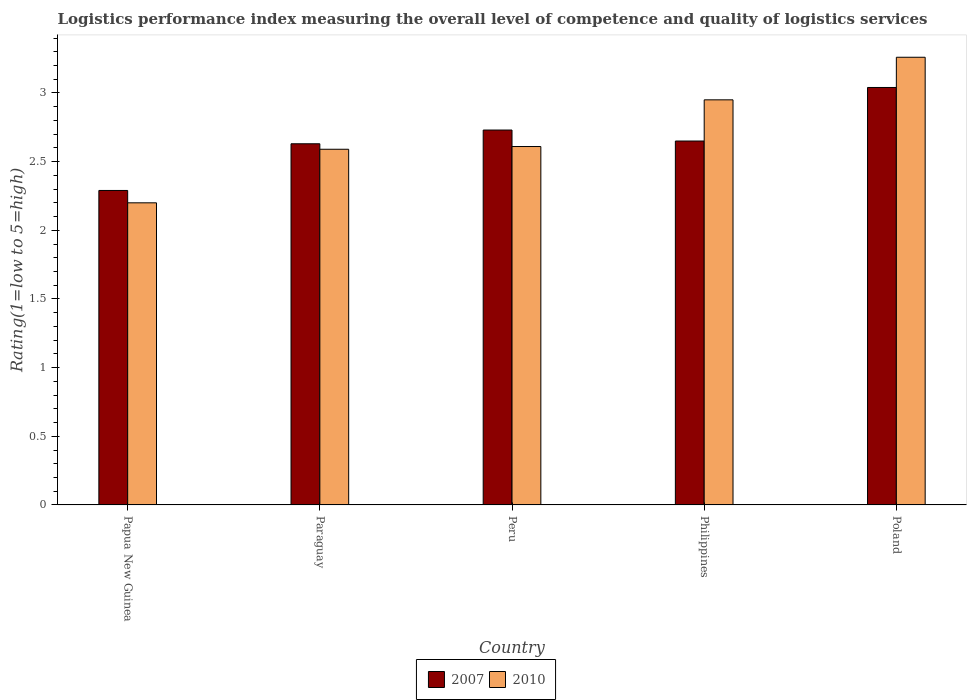How many different coloured bars are there?
Offer a terse response. 2. Are the number of bars per tick equal to the number of legend labels?
Offer a very short reply. Yes. How many bars are there on the 4th tick from the right?
Offer a terse response. 2. What is the label of the 2nd group of bars from the left?
Provide a succinct answer. Paraguay. What is the Logistic performance index in 2007 in Peru?
Your response must be concise. 2.73. Across all countries, what is the maximum Logistic performance index in 2007?
Your response must be concise. 3.04. In which country was the Logistic performance index in 2007 maximum?
Give a very brief answer. Poland. In which country was the Logistic performance index in 2010 minimum?
Provide a short and direct response. Papua New Guinea. What is the total Logistic performance index in 2010 in the graph?
Keep it short and to the point. 13.61. What is the difference between the Logistic performance index in 2010 in Philippines and that in Poland?
Provide a succinct answer. -0.31. What is the difference between the Logistic performance index in 2007 in Paraguay and the Logistic performance index in 2010 in Philippines?
Keep it short and to the point. -0.32. What is the average Logistic performance index in 2010 per country?
Your response must be concise. 2.72. What is the difference between the Logistic performance index of/in 2010 and Logistic performance index of/in 2007 in Philippines?
Your answer should be compact. 0.3. What is the ratio of the Logistic performance index in 2010 in Paraguay to that in Poland?
Make the answer very short. 0.79. Is the Logistic performance index in 2007 in Paraguay less than that in Philippines?
Offer a very short reply. Yes. What is the difference between the highest and the second highest Logistic performance index in 2010?
Provide a succinct answer. -0.34. What is the difference between the highest and the lowest Logistic performance index in 2010?
Ensure brevity in your answer.  1.06. What does the 2nd bar from the left in Poland represents?
Your answer should be very brief. 2010. What does the 2nd bar from the right in Peru represents?
Your answer should be compact. 2007. How many bars are there?
Provide a short and direct response. 10. Are all the bars in the graph horizontal?
Keep it short and to the point. No. What is the difference between two consecutive major ticks on the Y-axis?
Give a very brief answer. 0.5. Does the graph contain any zero values?
Ensure brevity in your answer.  No. How many legend labels are there?
Offer a terse response. 2. What is the title of the graph?
Make the answer very short. Logistics performance index measuring the overall level of competence and quality of logistics services. Does "1973" appear as one of the legend labels in the graph?
Provide a short and direct response. No. What is the label or title of the X-axis?
Your answer should be compact. Country. What is the label or title of the Y-axis?
Make the answer very short. Rating(1=low to 5=high). What is the Rating(1=low to 5=high) in 2007 in Papua New Guinea?
Give a very brief answer. 2.29. What is the Rating(1=low to 5=high) of 2010 in Papua New Guinea?
Make the answer very short. 2.2. What is the Rating(1=low to 5=high) in 2007 in Paraguay?
Give a very brief answer. 2.63. What is the Rating(1=low to 5=high) in 2010 in Paraguay?
Make the answer very short. 2.59. What is the Rating(1=low to 5=high) of 2007 in Peru?
Offer a terse response. 2.73. What is the Rating(1=low to 5=high) of 2010 in Peru?
Your response must be concise. 2.61. What is the Rating(1=low to 5=high) of 2007 in Philippines?
Your answer should be very brief. 2.65. What is the Rating(1=low to 5=high) in 2010 in Philippines?
Make the answer very short. 2.95. What is the Rating(1=low to 5=high) in 2007 in Poland?
Ensure brevity in your answer.  3.04. What is the Rating(1=low to 5=high) of 2010 in Poland?
Provide a succinct answer. 3.26. Across all countries, what is the maximum Rating(1=low to 5=high) in 2007?
Your response must be concise. 3.04. Across all countries, what is the maximum Rating(1=low to 5=high) in 2010?
Keep it short and to the point. 3.26. Across all countries, what is the minimum Rating(1=low to 5=high) of 2007?
Ensure brevity in your answer.  2.29. What is the total Rating(1=low to 5=high) in 2007 in the graph?
Keep it short and to the point. 13.34. What is the total Rating(1=low to 5=high) of 2010 in the graph?
Provide a succinct answer. 13.61. What is the difference between the Rating(1=low to 5=high) of 2007 in Papua New Guinea and that in Paraguay?
Your answer should be very brief. -0.34. What is the difference between the Rating(1=low to 5=high) in 2010 in Papua New Guinea and that in Paraguay?
Keep it short and to the point. -0.39. What is the difference between the Rating(1=low to 5=high) of 2007 in Papua New Guinea and that in Peru?
Your answer should be very brief. -0.44. What is the difference between the Rating(1=low to 5=high) of 2010 in Papua New Guinea and that in Peru?
Provide a succinct answer. -0.41. What is the difference between the Rating(1=low to 5=high) in 2007 in Papua New Guinea and that in Philippines?
Keep it short and to the point. -0.36. What is the difference between the Rating(1=low to 5=high) of 2010 in Papua New Guinea and that in Philippines?
Make the answer very short. -0.75. What is the difference between the Rating(1=low to 5=high) in 2007 in Papua New Guinea and that in Poland?
Ensure brevity in your answer.  -0.75. What is the difference between the Rating(1=low to 5=high) in 2010 in Papua New Guinea and that in Poland?
Offer a very short reply. -1.06. What is the difference between the Rating(1=low to 5=high) of 2007 in Paraguay and that in Peru?
Your response must be concise. -0.1. What is the difference between the Rating(1=low to 5=high) in 2010 in Paraguay and that in Peru?
Offer a very short reply. -0.02. What is the difference between the Rating(1=low to 5=high) of 2007 in Paraguay and that in Philippines?
Provide a short and direct response. -0.02. What is the difference between the Rating(1=low to 5=high) of 2010 in Paraguay and that in Philippines?
Offer a terse response. -0.36. What is the difference between the Rating(1=low to 5=high) in 2007 in Paraguay and that in Poland?
Your answer should be very brief. -0.41. What is the difference between the Rating(1=low to 5=high) of 2010 in Paraguay and that in Poland?
Provide a short and direct response. -0.67. What is the difference between the Rating(1=low to 5=high) in 2010 in Peru and that in Philippines?
Provide a succinct answer. -0.34. What is the difference between the Rating(1=low to 5=high) in 2007 in Peru and that in Poland?
Keep it short and to the point. -0.31. What is the difference between the Rating(1=low to 5=high) of 2010 in Peru and that in Poland?
Give a very brief answer. -0.65. What is the difference between the Rating(1=low to 5=high) in 2007 in Philippines and that in Poland?
Ensure brevity in your answer.  -0.39. What is the difference between the Rating(1=low to 5=high) in 2010 in Philippines and that in Poland?
Provide a short and direct response. -0.31. What is the difference between the Rating(1=low to 5=high) of 2007 in Papua New Guinea and the Rating(1=low to 5=high) of 2010 in Paraguay?
Your response must be concise. -0.3. What is the difference between the Rating(1=low to 5=high) of 2007 in Papua New Guinea and the Rating(1=low to 5=high) of 2010 in Peru?
Make the answer very short. -0.32. What is the difference between the Rating(1=low to 5=high) of 2007 in Papua New Guinea and the Rating(1=low to 5=high) of 2010 in Philippines?
Provide a short and direct response. -0.66. What is the difference between the Rating(1=low to 5=high) in 2007 in Papua New Guinea and the Rating(1=low to 5=high) in 2010 in Poland?
Give a very brief answer. -0.97. What is the difference between the Rating(1=low to 5=high) of 2007 in Paraguay and the Rating(1=low to 5=high) of 2010 in Philippines?
Give a very brief answer. -0.32. What is the difference between the Rating(1=low to 5=high) of 2007 in Paraguay and the Rating(1=low to 5=high) of 2010 in Poland?
Provide a short and direct response. -0.63. What is the difference between the Rating(1=low to 5=high) of 2007 in Peru and the Rating(1=low to 5=high) of 2010 in Philippines?
Your answer should be very brief. -0.22. What is the difference between the Rating(1=low to 5=high) of 2007 in Peru and the Rating(1=low to 5=high) of 2010 in Poland?
Make the answer very short. -0.53. What is the difference between the Rating(1=low to 5=high) of 2007 in Philippines and the Rating(1=low to 5=high) of 2010 in Poland?
Keep it short and to the point. -0.61. What is the average Rating(1=low to 5=high) of 2007 per country?
Ensure brevity in your answer.  2.67. What is the average Rating(1=low to 5=high) of 2010 per country?
Your answer should be very brief. 2.72. What is the difference between the Rating(1=low to 5=high) of 2007 and Rating(1=low to 5=high) of 2010 in Papua New Guinea?
Offer a terse response. 0.09. What is the difference between the Rating(1=low to 5=high) in 2007 and Rating(1=low to 5=high) in 2010 in Peru?
Give a very brief answer. 0.12. What is the difference between the Rating(1=low to 5=high) of 2007 and Rating(1=low to 5=high) of 2010 in Poland?
Provide a short and direct response. -0.22. What is the ratio of the Rating(1=low to 5=high) of 2007 in Papua New Guinea to that in Paraguay?
Your response must be concise. 0.87. What is the ratio of the Rating(1=low to 5=high) of 2010 in Papua New Guinea to that in Paraguay?
Keep it short and to the point. 0.85. What is the ratio of the Rating(1=low to 5=high) of 2007 in Papua New Guinea to that in Peru?
Provide a succinct answer. 0.84. What is the ratio of the Rating(1=low to 5=high) in 2010 in Papua New Guinea to that in Peru?
Your response must be concise. 0.84. What is the ratio of the Rating(1=low to 5=high) of 2007 in Papua New Guinea to that in Philippines?
Your answer should be very brief. 0.86. What is the ratio of the Rating(1=low to 5=high) in 2010 in Papua New Guinea to that in Philippines?
Give a very brief answer. 0.75. What is the ratio of the Rating(1=low to 5=high) in 2007 in Papua New Guinea to that in Poland?
Your response must be concise. 0.75. What is the ratio of the Rating(1=low to 5=high) in 2010 in Papua New Guinea to that in Poland?
Make the answer very short. 0.67. What is the ratio of the Rating(1=low to 5=high) in 2007 in Paraguay to that in Peru?
Give a very brief answer. 0.96. What is the ratio of the Rating(1=low to 5=high) of 2010 in Paraguay to that in Peru?
Your answer should be very brief. 0.99. What is the ratio of the Rating(1=low to 5=high) in 2010 in Paraguay to that in Philippines?
Provide a succinct answer. 0.88. What is the ratio of the Rating(1=low to 5=high) in 2007 in Paraguay to that in Poland?
Provide a short and direct response. 0.87. What is the ratio of the Rating(1=low to 5=high) in 2010 in Paraguay to that in Poland?
Give a very brief answer. 0.79. What is the ratio of the Rating(1=low to 5=high) in 2007 in Peru to that in Philippines?
Your answer should be compact. 1.03. What is the ratio of the Rating(1=low to 5=high) of 2010 in Peru to that in Philippines?
Keep it short and to the point. 0.88. What is the ratio of the Rating(1=low to 5=high) of 2007 in Peru to that in Poland?
Your answer should be very brief. 0.9. What is the ratio of the Rating(1=low to 5=high) in 2010 in Peru to that in Poland?
Your answer should be very brief. 0.8. What is the ratio of the Rating(1=low to 5=high) in 2007 in Philippines to that in Poland?
Keep it short and to the point. 0.87. What is the ratio of the Rating(1=low to 5=high) in 2010 in Philippines to that in Poland?
Offer a terse response. 0.9. What is the difference between the highest and the second highest Rating(1=low to 5=high) in 2007?
Your response must be concise. 0.31. What is the difference between the highest and the second highest Rating(1=low to 5=high) of 2010?
Make the answer very short. 0.31. What is the difference between the highest and the lowest Rating(1=low to 5=high) in 2010?
Offer a terse response. 1.06. 